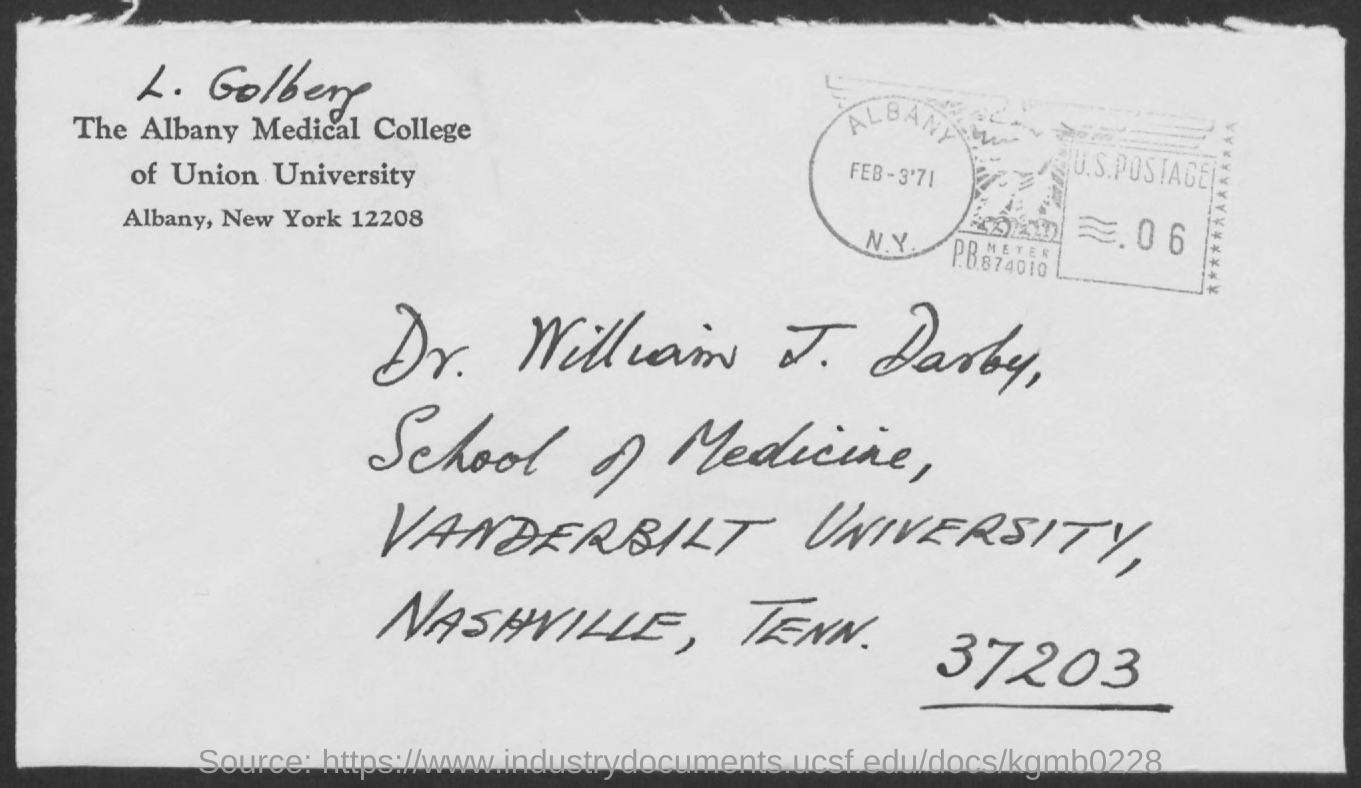Who is from Vanderbilt University as per the address?
Keep it short and to the point. Dr. William J. Darby,. Who is from The Albany Medical College of Union University as per the address?
Offer a terse response. L. Golberg. 